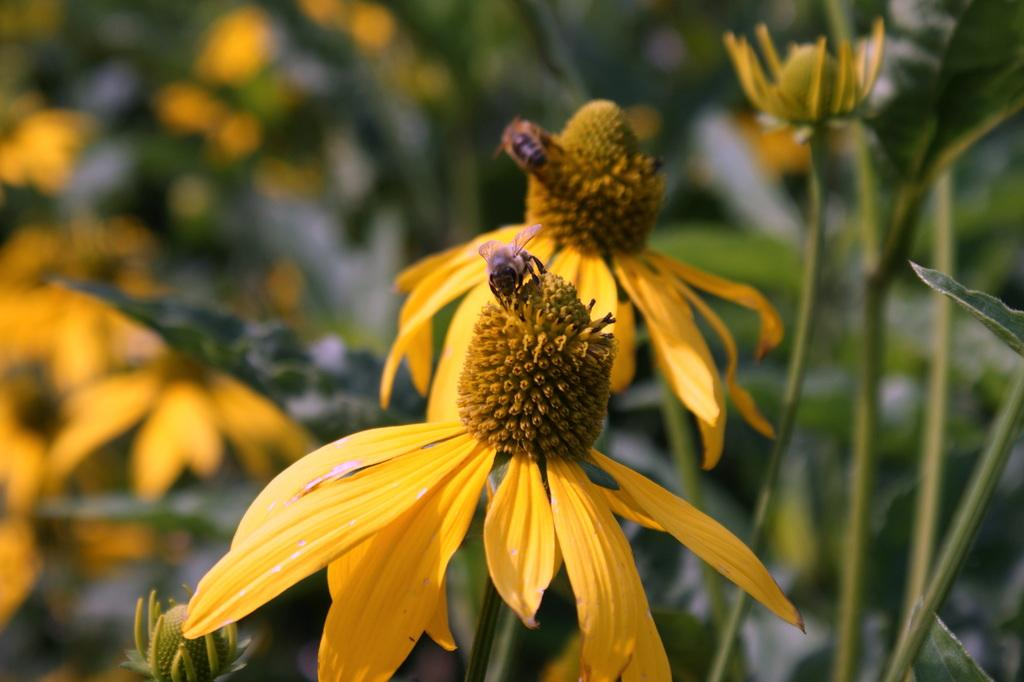What insects can be seen in the image? There are honey bees on the flowers in the image. What type of vegetation is visible in the background of the image? There are plants, flowers, and buds in the background of the image. What type of board can be seen in the image? There is no board present in the image. Can you tell me how many wrens are perched on the flowers in the image? There are no wrens present in the image; only honey bees can be seen on the flowers. 